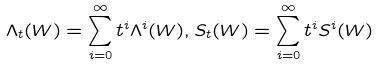Convert formula to latex. <formula><loc_0><loc_0><loc_500><loc_500>\Lambda _ { t } ( W ) = \sum _ { i = 0 } ^ { \infty } t ^ { i } \Lambda ^ { i } ( W ) , S _ { t } ( W ) = \sum _ { i = 0 } ^ { \infty } t ^ { i } S ^ { i } ( W )</formula> 